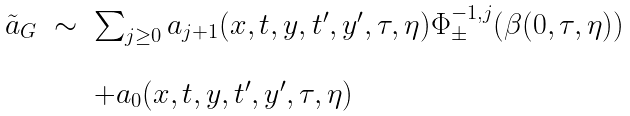<formula> <loc_0><loc_0><loc_500><loc_500>\begin{array} { l l l } \tilde { a } _ { G } & \sim & \sum _ { j \geq 0 } a _ { j + 1 } ( x , t , y , t ^ { \prime } , y ^ { \prime } , \tau , \eta ) \Phi _ { \pm } ^ { - 1 , j } ( \beta ( 0 , \tau , \eta ) ) \\ & & \\ & & + a _ { 0 } ( x , t , y , t ^ { \prime } , y ^ { \prime } , \tau , \eta ) \end{array}</formula> 